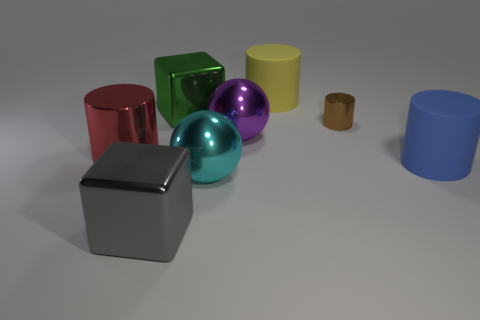Add 1 cyan matte cylinders. How many objects exist? 9 Subtract all balls. How many objects are left? 6 Subtract all big red rubber things. Subtract all shiny things. How many objects are left? 2 Add 4 red things. How many red things are left? 5 Add 1 big blue objects. How many big blue objects exist? 2 Subtract 0 cyan cylinders. How many objects are left? 8 